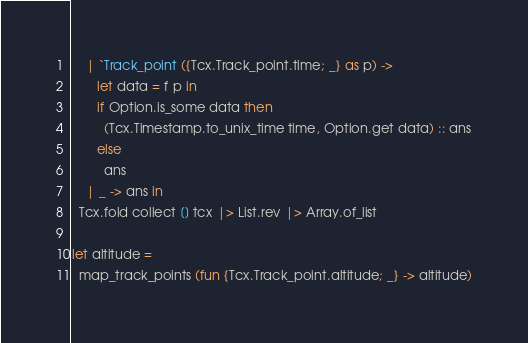Convert code to text. <code><loc_0><loc_0><loc_500><loc_500><_OCaml_>    | `Track_point ({Tcx.Track_point.time; _} as p) ->
       let data = f p in
       if Option.is_some data then
         (Tcx.Timestamp.to_unix_time time, Option.get data) :: ans
       else
         ans
    | _ -> ans in
  Tcx.fold collect [] tcx |> List.rev |> Array.of_list

let altitude =
  map_track_points (fun {Tcx.Track_point.altitude; _} -> altitude)
</code> 